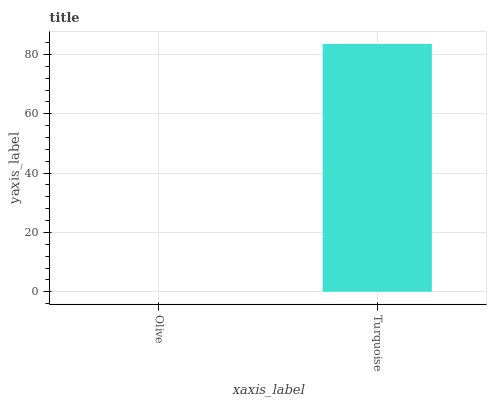Is Olive the minimum?
Answer yes or no. Yes. Is Turquoise the maximum?
Answer yes or no. Yes. Is Turquoise the minimum?
Answer yes or no. No. Is Turquoise greater than Olive?
Answer yes or no. Yes. Is Olive less than Turquoise?
Answer yes or no. Yes. Is Olive greater than Turquoise?
Answer yes or no. No. Is Turquoise less than Olive?
Answer yes or no. No. Is Turquoise the high median?
Answer yes or no. Yes. Is Olive the low median?
Answer yes or no. Yes. Is Olive the high median?
Answer yes or no. No. Is Turquoise the low median?
Answer yes or no. No. 